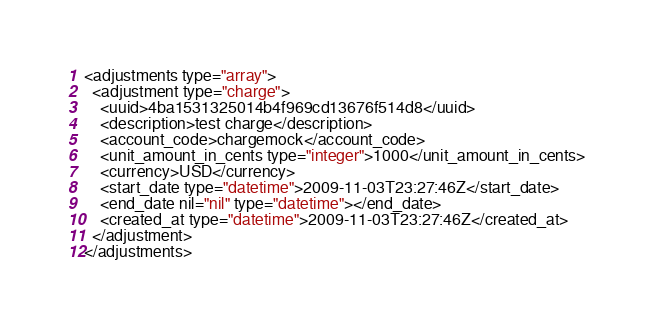Convert code to text. <code><loc_0><loc_0><loc_500><loc_500><_XML_>
<adjustments type="array">
  <adjustment type="charge">
    <uuid>4ba1531325014b4f969cd13676f514d8</uuid>
    <description>test charge</description>
    <account_code>chargemock</account_code>
    <unit_amount_in_cents type="integer">1000</unit_amount_in_cents>
    <currency>USD</currency>
    <start_date type="datetime">2009-11-03T23:27:46Z</start_date>
    <end_date nil="nil" type="datetime"></end_date>
    <created_at type="datetime">2009-11-03T23:27:46Z</created_at>
  </adjustment>
</adjustments>
</code> 